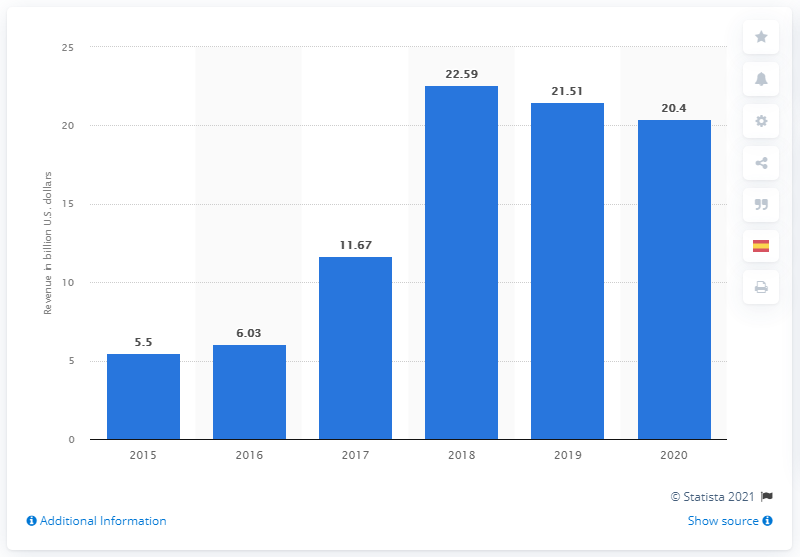Indicate a few pertinent items in this graphic. In 2020, DuPont generated a revenue of 20.4 billion US dollars. 